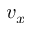Convert formula to latex. <formula><loc_0><loc_0><loc_500><loc_500>v _ { x }</formula> 